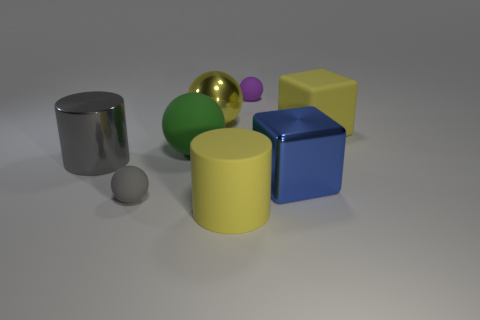Subtract all shiny spheres. How many spheres are left? 3 Add 1 big yellow shiny spheres. How many objects exist? 9 Subtract all purple balls. How many balls are left? 3 Subtract all blocks. How many objects are left? 6 Subtract 1 blocks. How many blocks are left? 1 Subtract all cyan blocks. How many purple balls are left? 1 Subtract all yellow cylinders. Subtract all big yellow balls. How many objects are left? 6 Add 2 large blue cubes. How many large blue cubes are left? 3 Add 8 brown cubes. How many brown cubes exist? 8 Subtract 0 purple cubes. How many objects are left? 8 